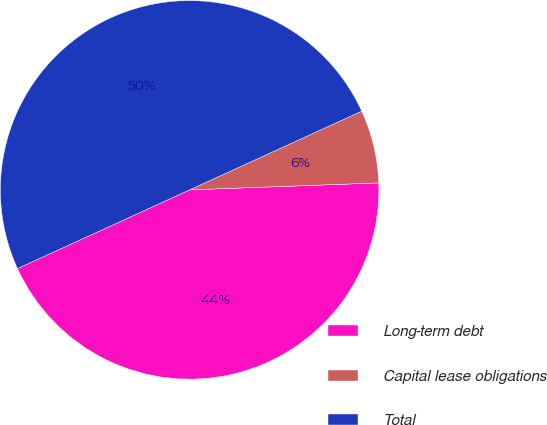Convert chart to OTSL. <chart><loc_0><loc_0><loc_500><loc_500><pie_chart><fcel>Long-term debt<fcel>Capital lease obligations<fcel>Total<nl><fcel>43.76%<fcel>6.24%<fcel>50.0%<nl></chart> 